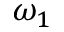<formula> <loc_0><loc_0><loc_500><loc_500>\omega _ { 1 }</formula> 